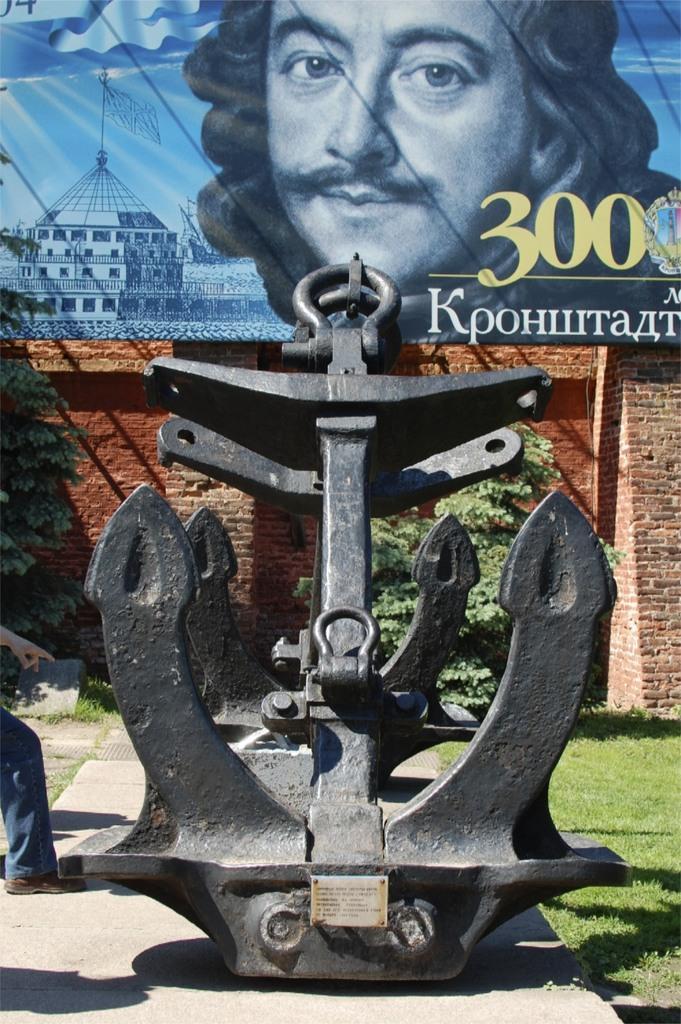How would you summarize this image in a sentence or two? In this image I can see an anchor, background I can see few plants in green color, the wall in brown color and I can also see the banner. In the banner I can see the person and few buildings and the banner is in blue color. 